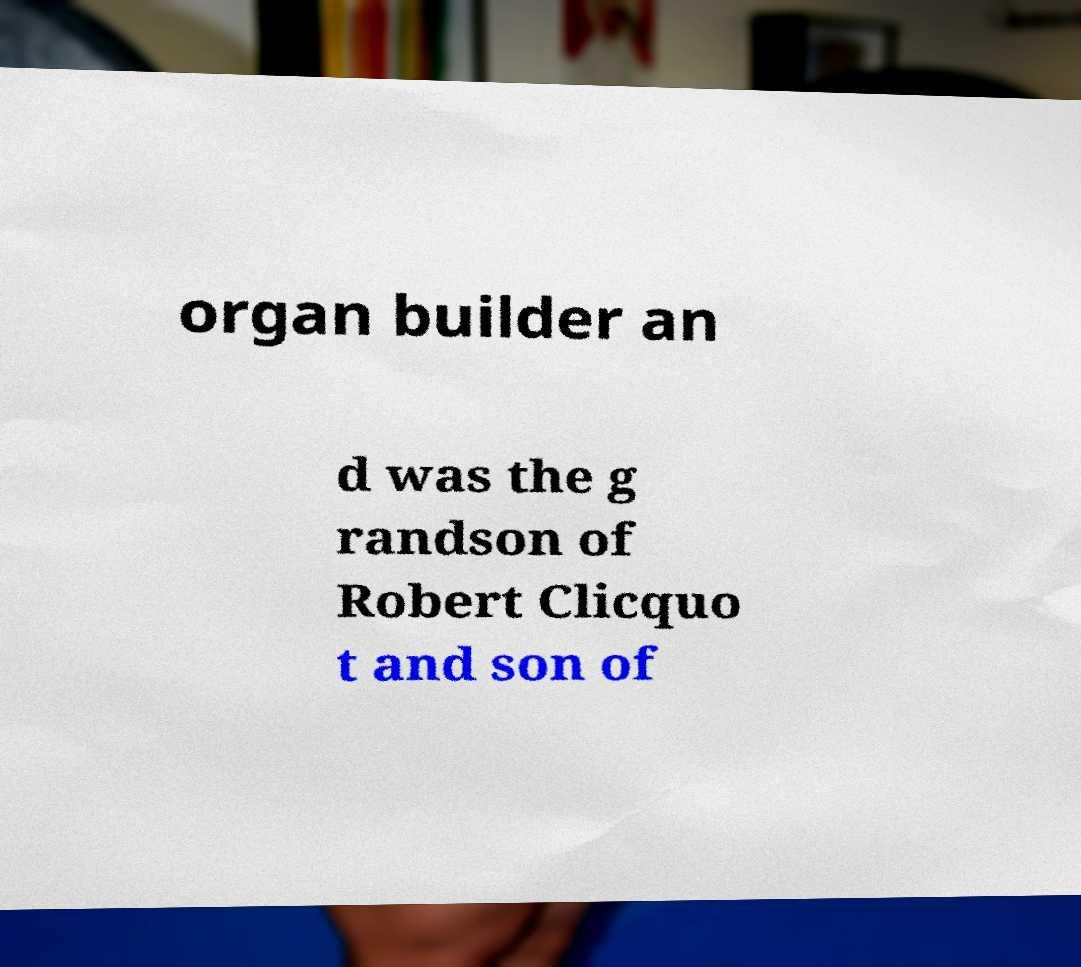What messages or text are displayed in this image? I need them in a readable, typed format. organ builder an d was the g randson of Robert Clicquo t and son of 